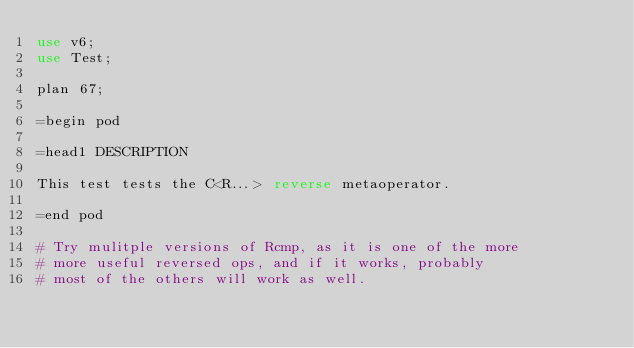Convert code to text. <code><loc_0><loc_0><loc_500><loc_500><_Perl_>use v6;
use Test;

plan 67;

=begin pod

=head1 DESCRIPTION

This test tests the C<R...> reverse metaoperator.

=end pod

# Try mulitple versions of Rcmp, as it is one of the more
# more useful reversed ops, and if it works, probably
# most of the others will work as well.
</code> 